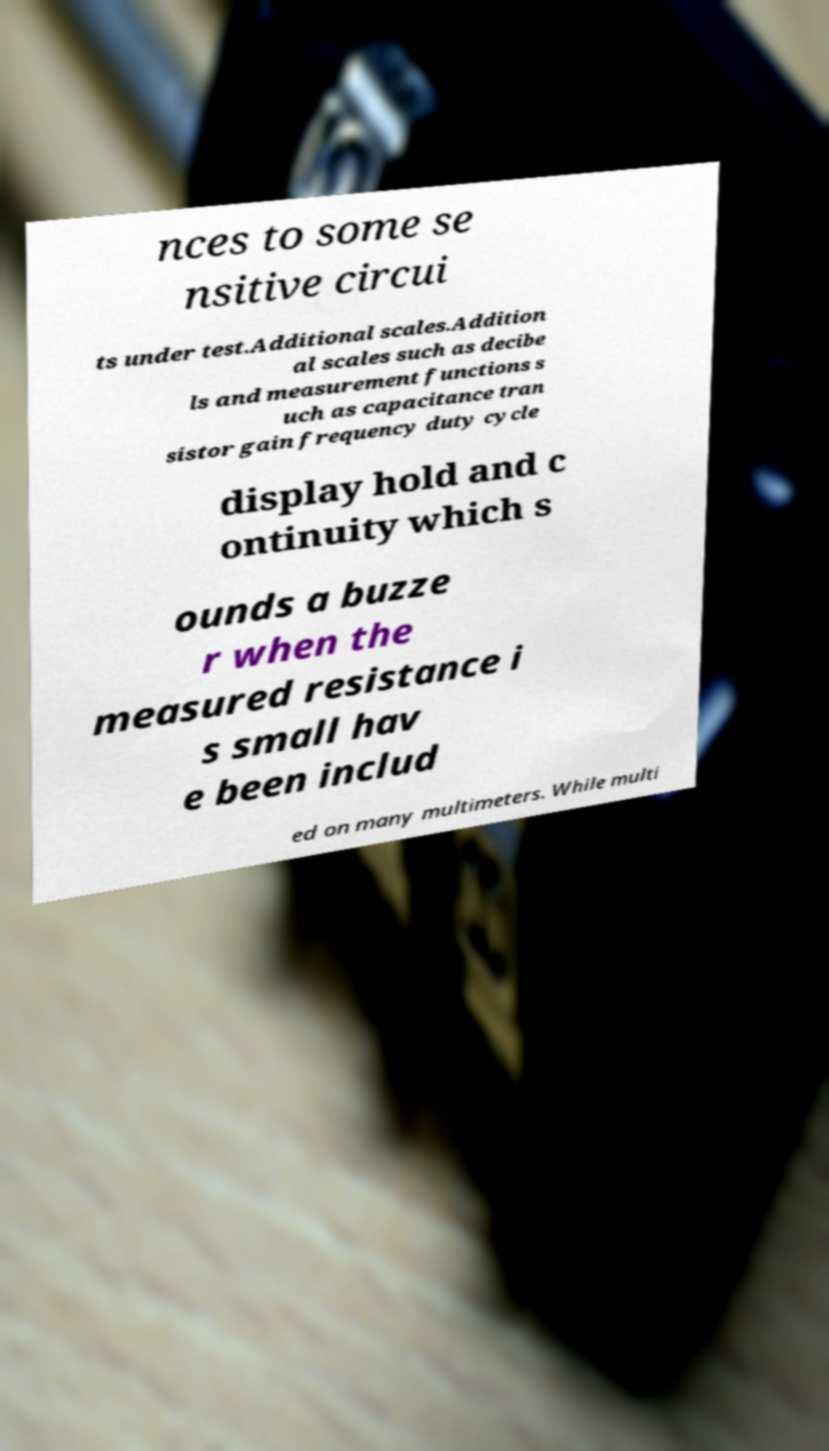Can you accurately transcribe the text from the provided image for me? nces to some se nsitive circui ts under test.Additional scales.Addition al scales such as decibe ls and measurement functions s uch as capacitance tran sistor gain frequency duty cycle display hold and c ontinuity which s ounds a buzze r when the measured resistance i s small hav e been includ ed on many multimeters. While multi 